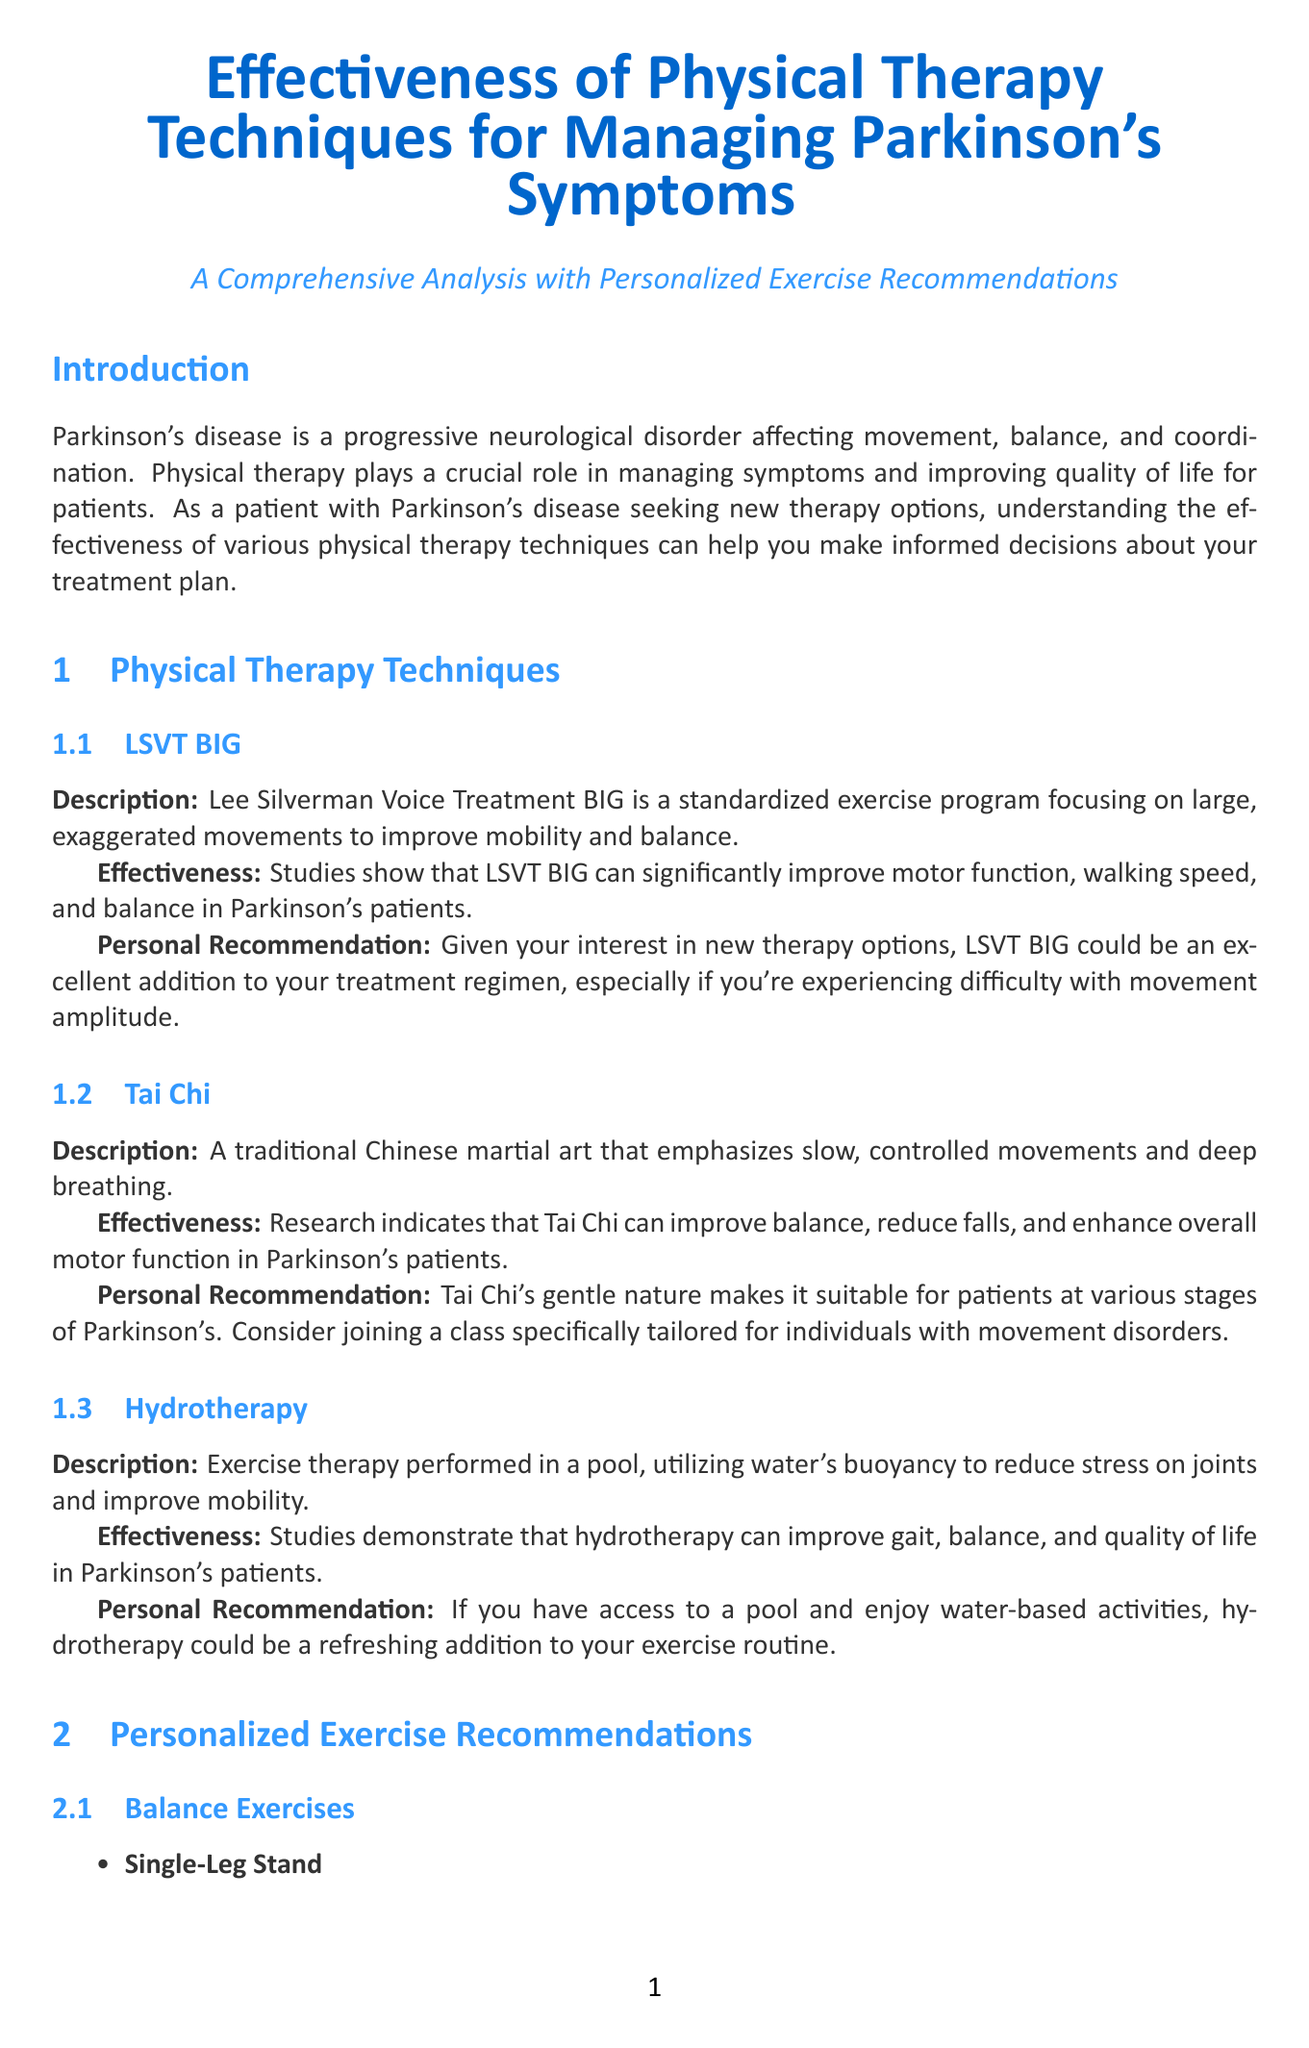What is the title of the report? The title of the report is stated in the document's heading.
Answer: Effectiveness of Physical Therapy Techniques for Managing Parkinson's Symptoms: A Comprehensive Analysis with Personalized Exercise Recommendations What technique focuses on large, exaggerated movements? This information can be found in the section discussing specific physical therapy techniques.
Answer: LSVT BIG Which technique is described as a traditional Chinese martial art? This information is provided in the section about different therapy techniques.
Answer: Tai Chi How often should the Single-Leg Stand exercise be performed? The recommended frequency for the Single-Leg Stand exercise is detailed in the exercise recommendations section.
Answer: Daily What is the main benefit of hydrotherapy listed in the report? The effectiveness of hydrotherapy is summarized, indicating its benefits for patients.
Answer: Improve gait Which exercise improves upper body strength? This is specified in the strength training exercises section of the document.
Answer: Wall Push-Ups What should patients consult to create a personalized exercise plan? The conclusion emphasizes the importance of consulting with a specific type of professional.
Answer: Physical therapist How many sets of Sit-to-Stand should be performed each week? This information is included in the frequency section of the strength training exercises.
Answer: 3 times a week 